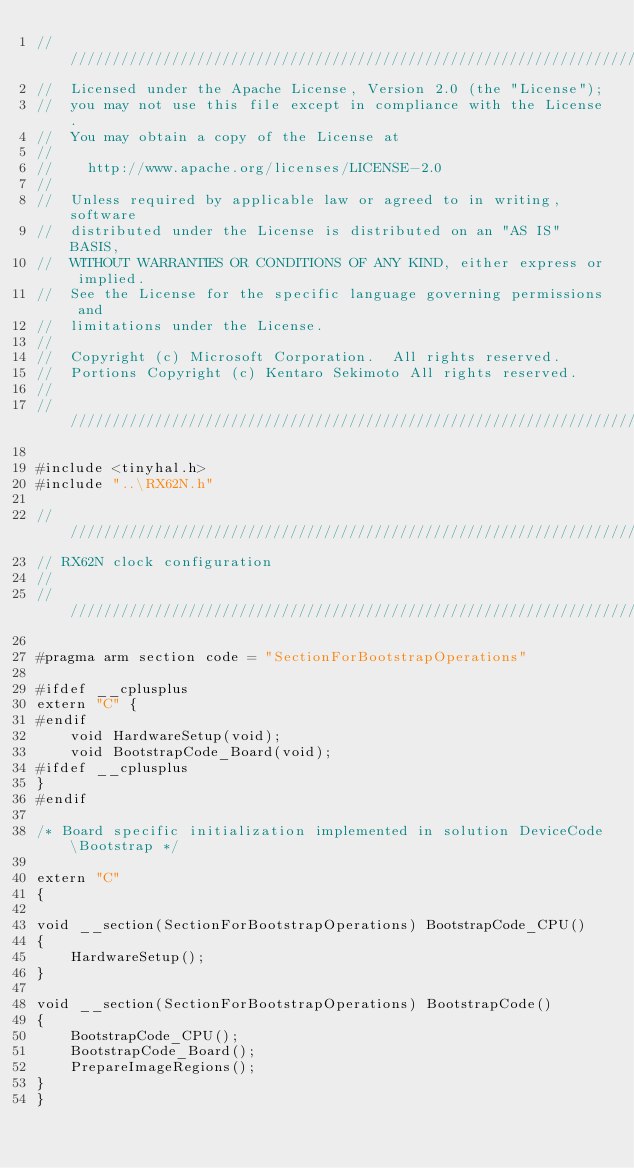<code> <loc_0><loc_0><loc_500><loc_500><_C++_>////////////////////////////////////////////////////////////////////////////
//  Licensed under the Apache License, Version 2.0 (the "License");
//  you may not use this file except in compliance with the License.
//  You may obtain a copy of the License at
//
//    http://www.apache.org/licenses/LICENSE-2.0
//
//  Unless required by applicable law or agreed to in writing, software
//  distributed under the License is distributed on an "AS IS" BASIS,
//  WITHOUT WARRANTIES OR CONDITIONS OF ANY KIND, either express or implied.
//  See the License for the specific language governing permissions and
//  limitations under the License.
//
//  Copyright (c) Microsoft Corporation.  All rights reserved.
//  Portions Copyright (c) Kentaro Sekimoto All rights reserved.
//
////////////////////////////////////////////////////////////////////////////

#include <tinyhal.h>
#include "..\RX62N.h"

///////////////////////////////////////////////////////////////////////////////
// RX62N clock configuration
//
///////////////////////////////////////////////////////////////////////////////

#pragma arm section code = "SectionForBootstrapOperations"

#ifdef __cplusplus
extern "C" {
#endif
    void HardwareSetup(void);
    void BootstrapCode_Board(void);
#ifdef __cplusplus
}
#endif

/* Board specific initialization implemented in solution DeviceCode\Bootstrap */

extern "C"
{

void __section(SectionForBootstrapOperations) BootstrapCode_CPU()
{
    HardwareSetup();
}

void __section(SectionForBootstrapOperations) BootstrapCode()
{
    BootstrapCode_CPU();
    BootstrapCode_Board();
    PrepareImageRegions();
}
}
</code> 